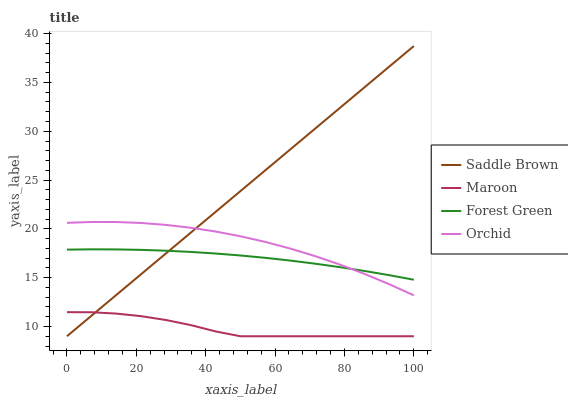Does Maroon have the minimum area under the curve?
Answer yes or no. Yes. Does Saddle Brown have the maximum area under the curve?
Answer yes or no. Yes. Does Saddle Brown have the minimum area under the curve?
Answer yes or no. No. Does Maroon have the maximum area under the curve?
Answer yes or no. No. Is Saddle Brown the smoothest?
Answer yes or no. Yes. Is Maroon the roughest?
Answer yes or no. Yes. Is Maroon the smoothest?
Answer yes or no. No. Is Saddle Brown the roughest?
Answer yes or no. No. Does Saddle Brown have the lowest value?
Answer yes or no. Yes. Does Orchid have the lowest value?
Answer yes or no. No. Does Saddle Brown have the highest value?
Answer yes or no. Yes. Does Maroon have the highest value?
Answer yes or no. No. Is Maroon less than Forest Green?
Answer yes or no. Yes. Is Orchid greater than Maroon?
Answer yes or no. Yes. Does Saddle Brown intersect Maroon?
Answer yes or no. Yes. Is Saddle Brown less than Maroon?
Answer yes or no. No. Is Saddle Brown greater than Maroon?
Answer yes or no. No. Does Maroon intersect Forest Green?
Answer yes or no. No. 